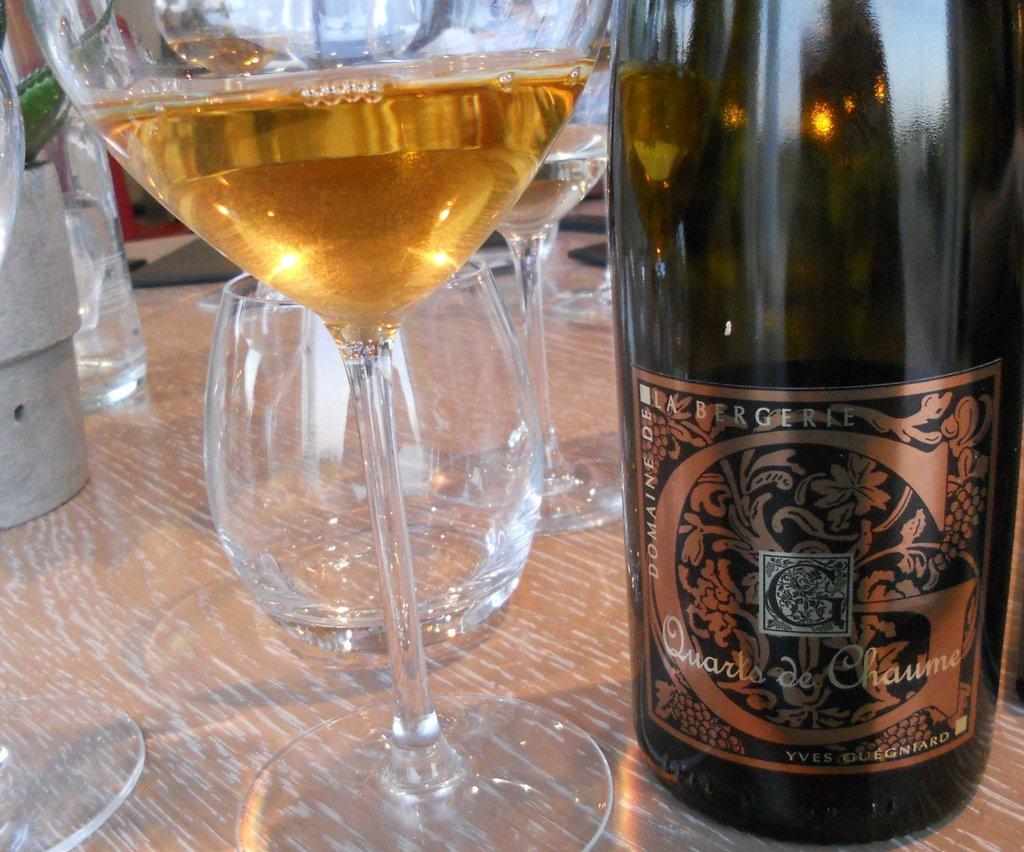<image>
Write a terse but informative summary of the picture. A bottle of Yves Guegniard wine and a glass containing some wine sit among other empty bar glasses. 